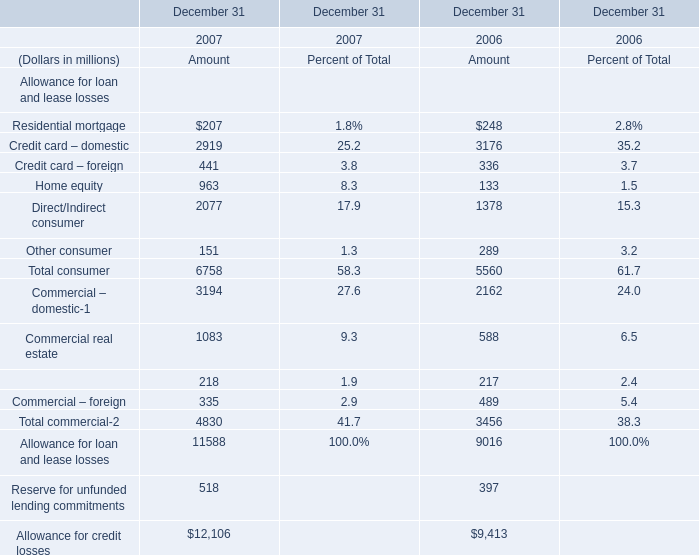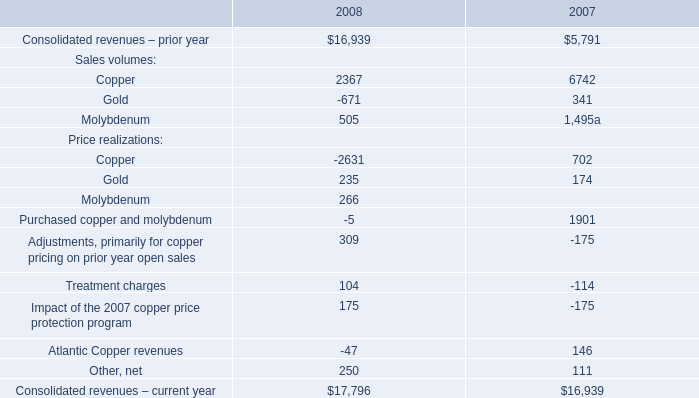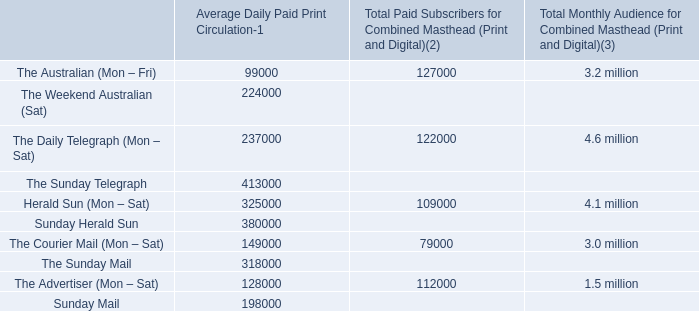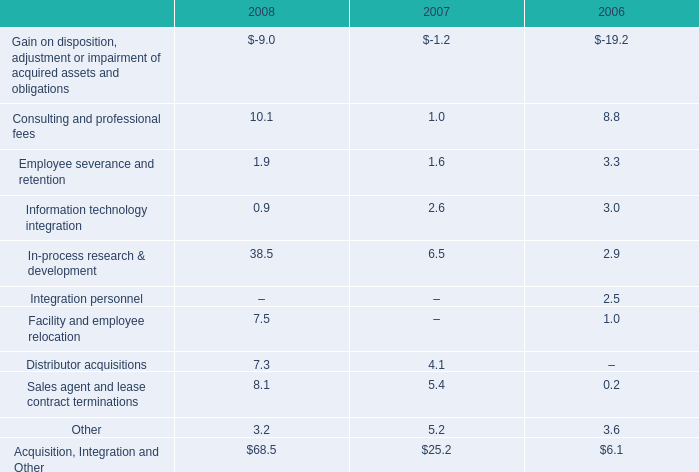what is the percent change in information technology integration from 2006 to 2007? 
Computations: ((3.0 - 2.6) / 2.6)
Answer: 0.15385. 